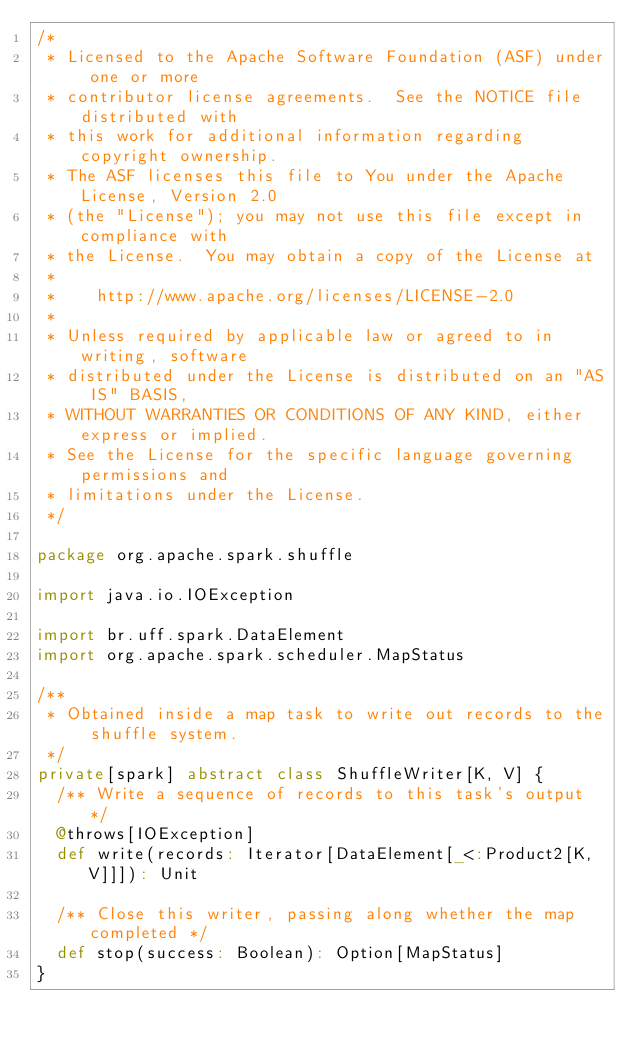<code> <loc_0><loc_0><loc_500><loc_500><_Scala_>/*
 * Licensed to the Apache Software Foundation (ASF) under one or more
 * contributor license agreements.  See the NOTICE file distributed with
 * this work for additional information regarding copyright ownership.
 * The ASF licenses this file to You under the Apache License, Version 2.0
 * (the "License"); you may not use this file except in compliance with
 * the License.  You may obtain a copy of the License at
 *
 *    http://www.apache.org/licenses/LICENSE-2.0
 *
 * Unless required by applicable law or agreed to in writing, software
 * distributed under the License is distributed on an "AS IS" BASIS,
 * WITHOUT WARRANTIES OR CONDITIONS OF ANY KIND, either express or implied.
 * See the License for the specific language governing permissions and
 * limitations under the License.
 */

package org.apache.spark.shuffle

import java.io.IOException

import br.uff.spark.DataElement
import org.apache.spark.scheduler.MapStatus

/**
 * Obtained inside a map task to write out records to the shuffle system.
 */
private[spark] abstract class ShuffleWriter[K, V] {
  /** Write a sequence of records to this task's output */
  @throws[IOException]
  def write(records: Iterator[DataElement[_<:Product2[K, V]]]): Unit

  /** Close this writer, passing along whether the map completed */
  def stop(success: Boolean): Option[MapStatus]
}
</code> 